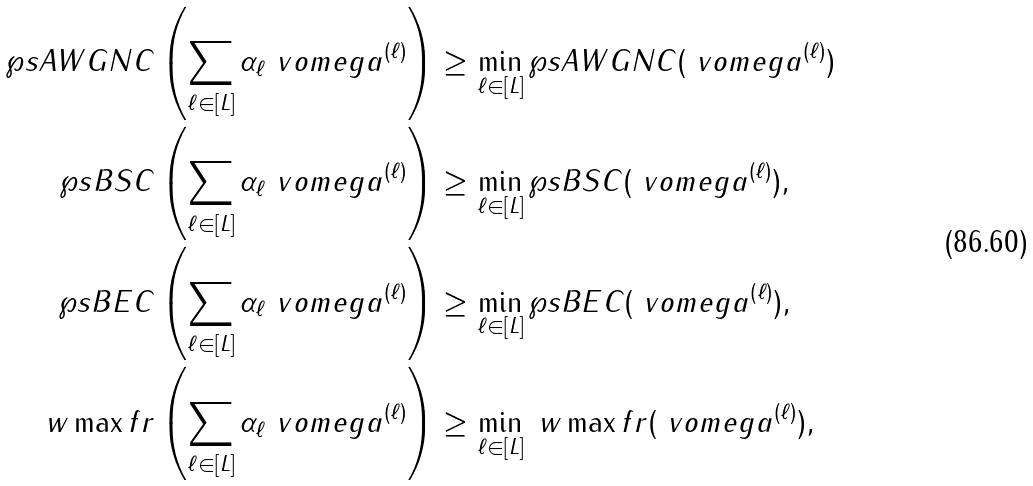<formula> <loc_0><loc_0><loc_500><loc_500>\wp s A W G N C \left ( \sum _ { \ell \in [ L ] } \alpha _ { \ell } \ v o m e g a ^ { ( \ell ) } \right ) & \geq \min _ { \ell \in [ L ] } \wp s A W G N C ( \ v o m e g a ^ { ( \ell ) } ) \\ \wp s B S C \left ( \sum _ { \ell \in [ L ] } \alpha _ { \ell } \ v o m e g a ^ { ( \ell ) } \right ) & \geq \min _ { \ell \in [ L ] } \wp s B S C ( \ v o m e g a ^ { ( \ell ) } ) , \\ \wp s B E C \left ( \sum _ { \ell \in [ L ] } \alpha _ { \ell } \ v o m e g a ^ { ( \ell ) } \right ) & \geq \min _ { \ell \in [ L ] } \wp s B E C ( \ v o m e g a ^ { ( \ell ) } ) , \\ \ w \max f r \left ( \sum _ { \ell \in [ L ] } \alpha _ { \ell } \ v o m e g a ^ { ( \ell ) } \right ) & \geq \min _ { \ell \in [ L ] } \ w \max f r ( \ v o m e g a ^ { ( \ell ) } ) ,</formula> 